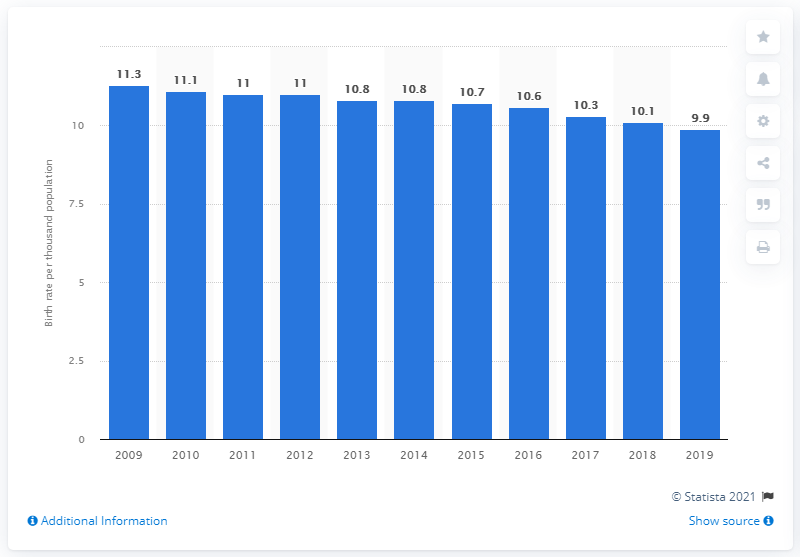Identify some key points in this picture. The crude birth rate in Canada in 2019 was 9.9. 